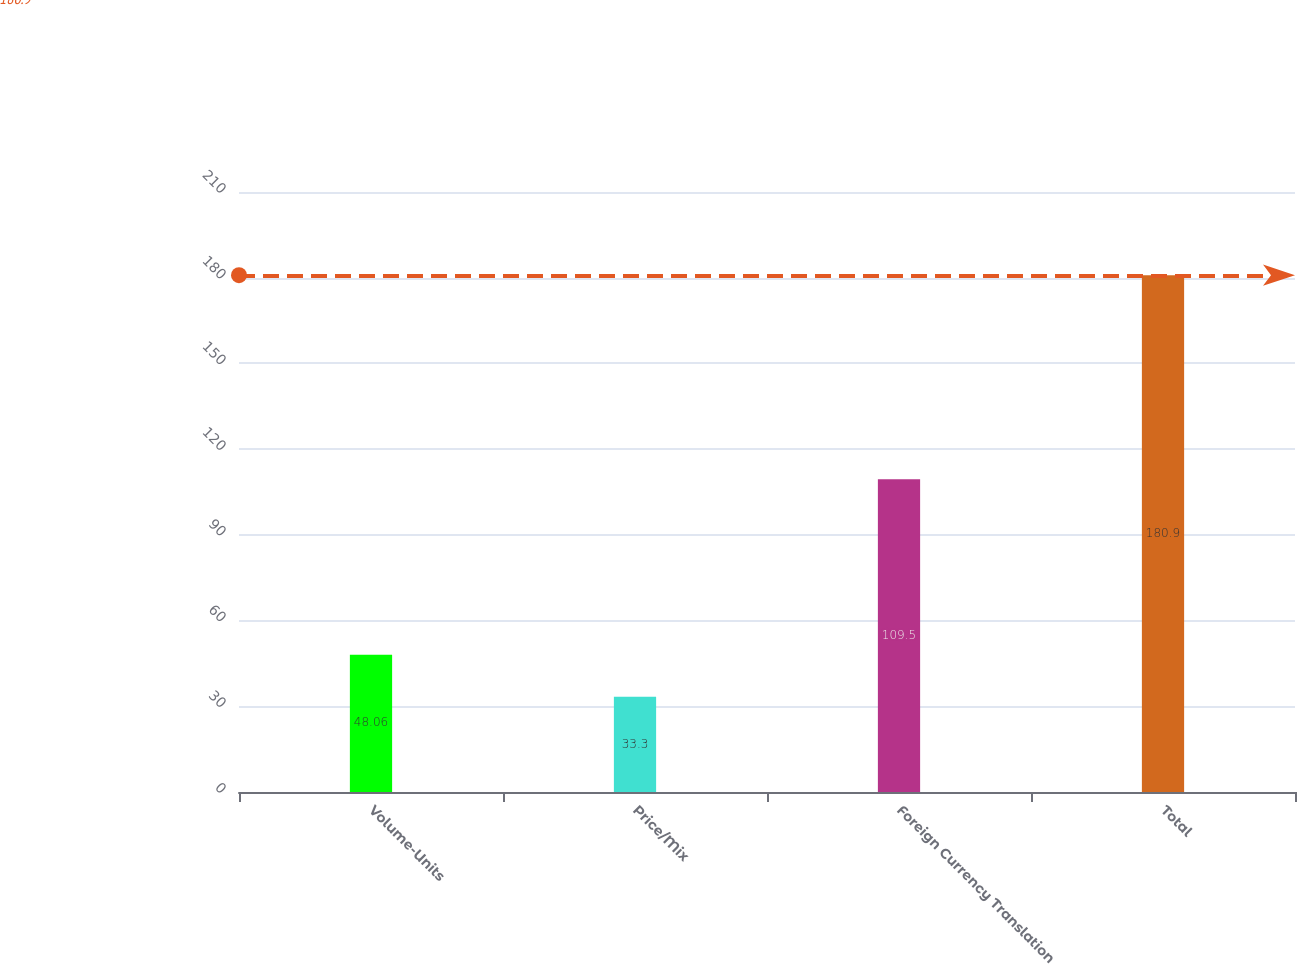Convert chart to OTSL. <chart><loc_0><loc_0><loc_500><loc_500><bar_chart><fcel>Volume-Units<fcel>Price/Mix<fcel>Foreign Currency Translation<fcel>Total<nl><fcel>48.06<fcel>33.3<fcel>109.5<fcel>180.9<nl></chart> 